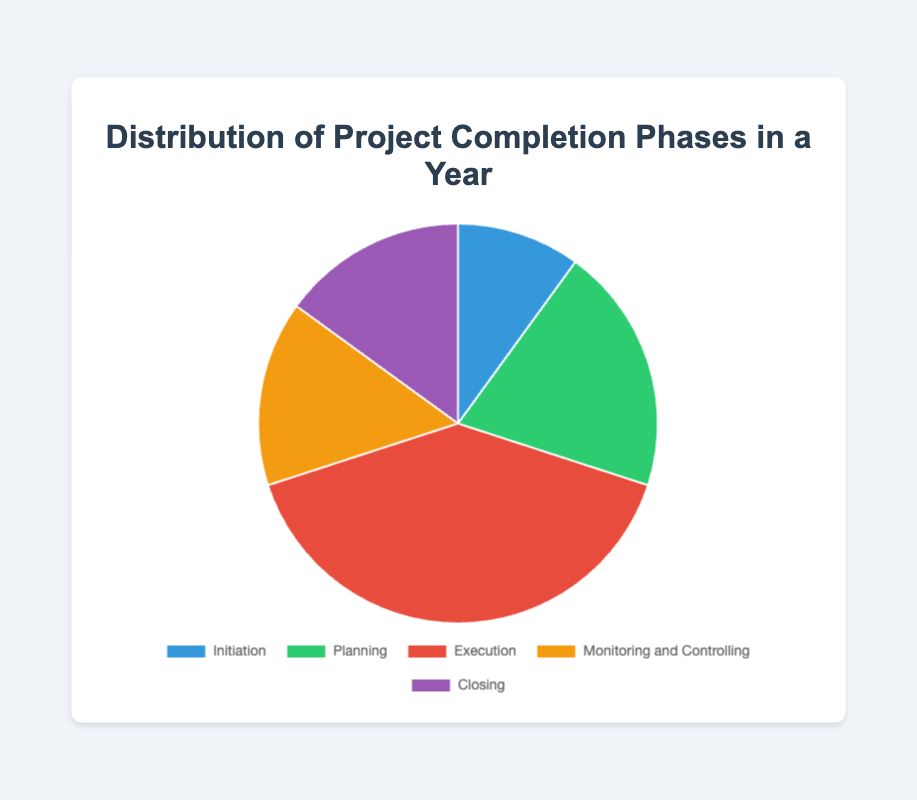What percentage of the project phases is represented by Closing and Initiation combined? Add the percentages of the Closing and Initiation phases: 15% (Closing) + 10% (Initiation) = 25%
Answer: 25% Which phase has the highest percentage of project completions? From the chart, the Execution phase has the highest percentage of project completions at 40%
Answer: Execution What is the difference in percentage between the Planning phase and the Monitoring and Controlling phase? Subtract the percentage of the Monitoring and Controlling phase from the Planning phase: 20% (Planning) - 15% (Monitoring and Controlling) = 5%
Answer: 5% How does the percentage of the Planning phase compare to the Initiation phase? The percentage of the Planning phase (20%) is higher than the Initiation phase (10%)
Answer: Planning phase has a higher percentage What do the colors red and green represent in the pie chart? In the pie chart, red represents the Execution phase, and green represents the Planning phase
Answer: Execution and Planning If the Initiation, Planning, and Closing phases were combined into one category, what would be their total percentage? Add the percentages of the Initiation, Planning, and Closing phases: 10% (Initiation) + 20% (Planning) + 15% (Closing) = 45%
Answer: 45% What percentage of the project phases is represented by non-Execution phases? Subtract the percentage of the Execution phase from 100%: 100% - 40% (Execution) = 60%
Answer: 60% Which two phases have the same percentage of completions? Both the Monitoring and Controlling phase and the Closing phase have the same percentage of completions at 15% each
Answer: Monitoring and Controlling and Closing Among the given phases, which one has the smallest share, and what is its percentage? The Inititaion phase has the smallest share, with a percentage of 10%
Answer: Initiation, 10% How do the combined percentages of Monitoring and Controlling and Closing compare to Execution? Add the percentages of Monitoring and Controlling and Closing: 15% + 15% = 30%. Then compare to Execution's 40%. 30% < 40%
Answer: Combined percentage is less 